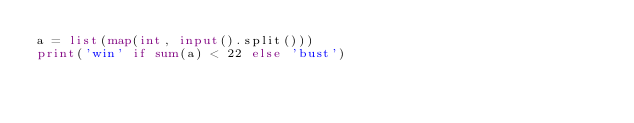Convert code to text. <code><loc_0><loc_0><loc_500><loc_500><_Python_>a = list(map(int, input().split()))
print('win' if sum(a) < 22 else 'bust')</code> 